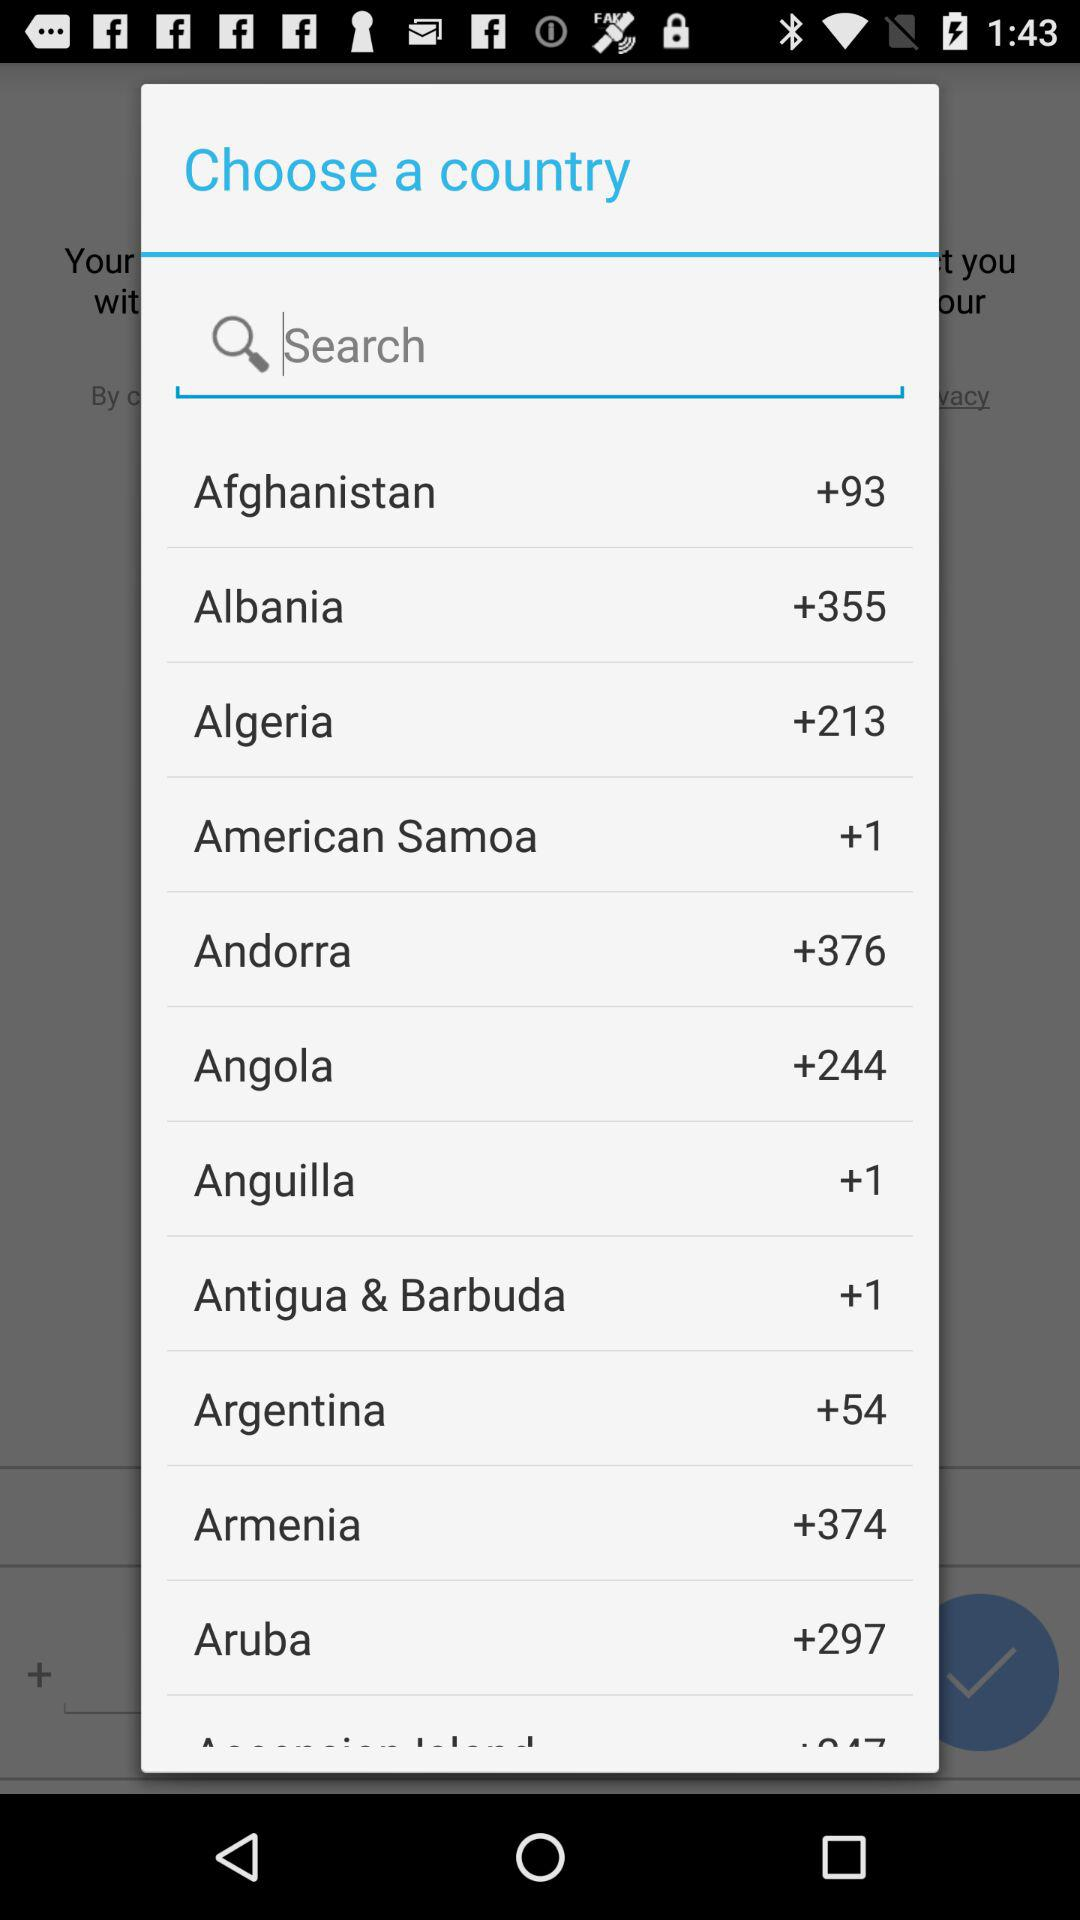What is the code for Afghanistan? The code for Afghanistan is +93. 